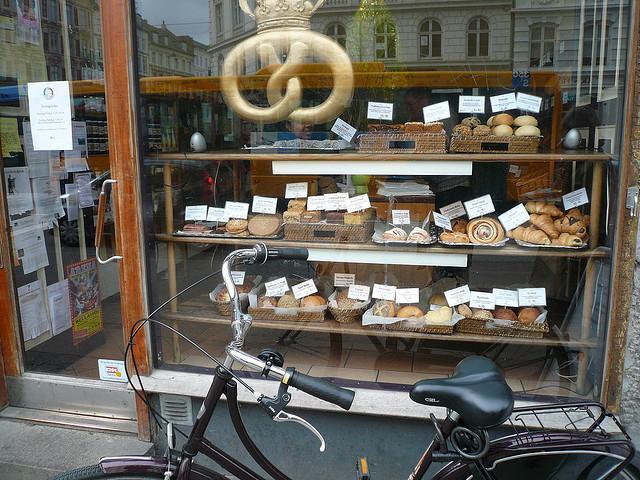How many price tags are on the top shelf?
Give a very brief answer. 6. How many wheels does the bike have?
Give a very brief answer. 2. How many giraffes can you see?
Give a very brief answer. 0. 